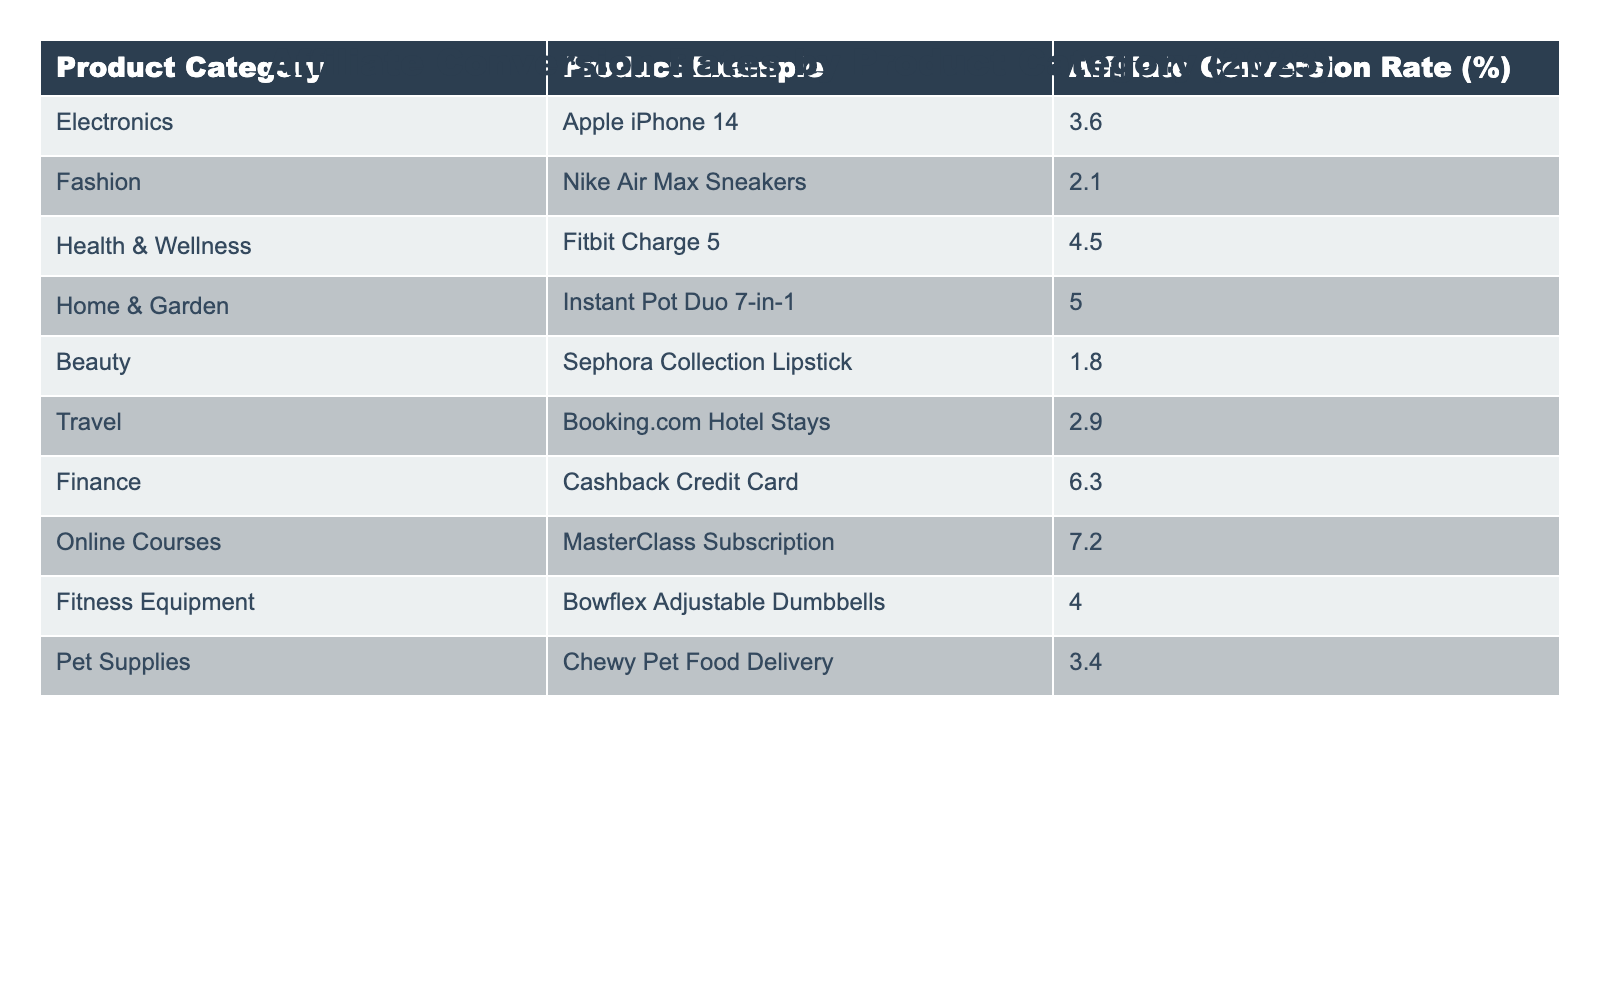What is the affiliate conversion rate for the "Health & Wellness" category? The table shows a specific entry for the "Health & Wellness" category, which lists a conversion rate of 4.5%.
Answer: 4.5% Which product category has the highest affiliate conversion rate in 2023? Looking through the table, the "Online Courses" category is highlighted with a conversion rate of 7.2%, which is the highest among all listed categories.
Answer: Online Courses What is the affiliate conversion rate for "Travel" products? The table indicates that the conversion rate for the "Travel" category, specifically for Booking.com Hotel Stays, is 2.9%.
Answer: 2.9% How many product categories have a conversion rate above 4%? By scanning the table, we find that the categories with rates above 4% are "Health & Wellness" (4.5%), "Home & Garden" (5.0%), "Finance" (6.3%), and "Online Courses" (7.2%), totaling four categories.
Answer: 4 What is the conversion rate difference between "Electronics" and "Beauty"? The table lists the conversion rate for "Electronics" at 3.6% and "Beauty" at 1.8%. Therefore, the difference is 3.6% - 1.8% = 1.8%.
Answer: 1.8% Is the conversion rate for "Fitness Equipment" higher than that for "Fashion"? The conversion rate for "Fitness Equipment" is 4.0%, while for "Fashion" it is 2.1%. Since 4.0% is greater than 2.1%, the statement is true.
Answer: Yes What is the average conversion rate of all product categories combined? To find the average, first sum the conversion rates: (3.6 + 2.1 + 4.5 + 5.0 + 1.8 + 2.9 + 6.3 + 7.2 + 4.0 + 3.4) = 35.8%. Then divide by the number of categories, which is 10, resulting in an average of 3.58%.
Answer: 3.58% What percentage of categories have conversion rates at or below 3%? The categories with rates at or below 3% are "Fashion" (2.1%) and "Travel" (2.9%), totaling 2 out of 10 categories. Thus, the percentage is (2/10) * 100 = 20%.
Answer: 20% Which conversion rate is the least among the listed categories? By examining all entries, the least conversion rate corresponds to "Beauty," which is 1.8%.
Answer: 1.8% What is the relationship between conversion rates in "Finance" and "Health & Wellness"? The conversion rate for "Finance" is 6.3% and for "Health & Wellness" is 4.5%. Since 6.3% is greater than 4.5%, one can conclude that the "Finance" category has a better conversion rate than "Health & Wellness."
Answer: Finance has a higher rate 